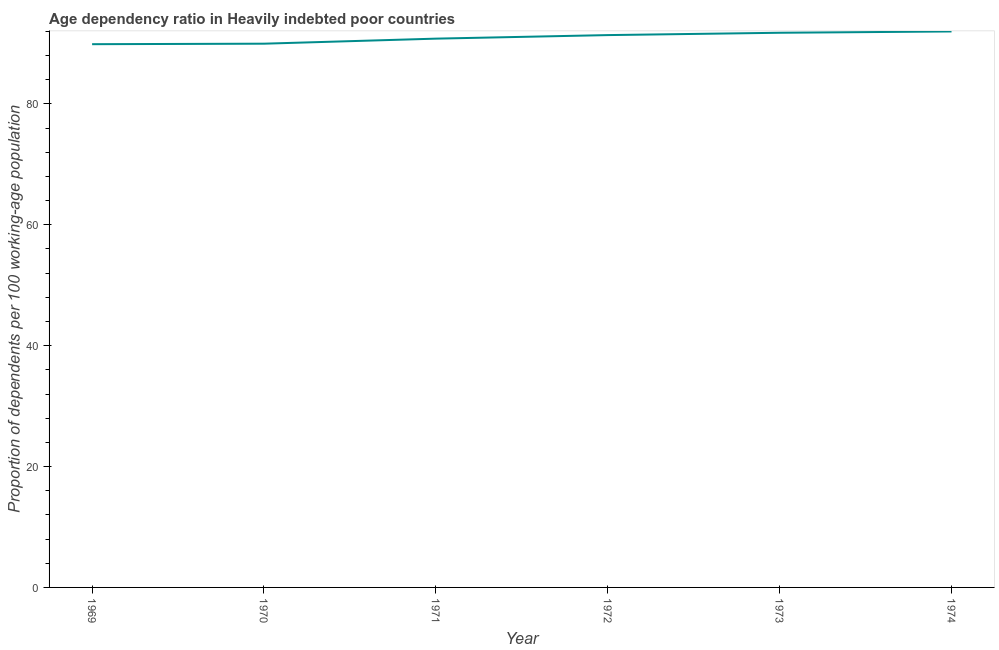What is the age dependency ratio in 1974?
Your answer should be compact. 91.99. Across all years, what is the maximum age dependency ratio?
Provide a short and direct response. 91.99. Across all years, what is the minimum age dependency ratio?
Offer a very short reply. 89.89. In which year was the age dependency ratio maximum?
Your answer should be very brief. 1974. In which year was the age dependency ratio minimum?
Your answer should be very brief. 1969. What is the sum of the age dependency ratio?
Your response must be concise. 545.82. What is the difference between the age dependency ratio in 1969 and 1972?
Your answer should be compact. -1.51. What is the average age dependency ratio per year?
Your answer should be compact. 90.97. What is the median age dependency ratio?
Provide a short and direct response. 91.1. What is the ratio of the age dependency ratio in 1973 to that in 1974?
Provide a short and direct response. 1. Is the age dependency ratio in 1971 less than that in 1974?
Make the answer very short. Yes. What is the difference between the highest and the second highest age dependency ratio?
Offer a very short reply. 0.22. What is the difference between the highest and the lowest age dependency ratio?
Your answer should be compact. 2.11. In how many years, is the age dependency ratio greater than the average age dependency ratio taken over all years?
Provide a succinct answer. 3. How many lines are there?
Give a very brief answer. 1. How many years are there in the graph?
Keep it short and to the point. 6. What is the difference between two consecutive major ticks on the Y-axis?
Your response must be concise. 20. Does the graph contain grids?
Give a very brief answer. No. What is the title of the graph?
Make the answer very short. Age dependency ratio in Heavily indebted poor countries. What is the label or title of the X-axis?
Make the answer very short. Year. What is the label or title of the Y-axis?
Give a very brief answer. Proportion of dependents per 100 working-age population. What is the Proportion of dependents per 100 working-age population of 1969?
Give a very brief answer. 89.89. What is the Proportion of dependents per 100 working-age population in 1970?
Provide a succinct answer. 89.97. What is the Proportion of dependents per 100 working-age population in 1971?
Provide a succinct answer. 90.8. What is the Proportion of dependents per 100 working-age population of 1972?
Keep it short and to the point. 91.39. What is the Proportion of dependents per 100 working-age population of 1973?
Your answer should be very brief. 91.78. What is the Proportion of dependents per 100 working-age population of 1974?
Provide a succinct answer. 91.99. What is the difference between the Proportion of dependents per 100 working-age population in 1969 and 1970?
Your response must be concise. -0.08. What is the difference between the Proportion of dependents per 100 working-age population in 1969 and 1971?
Offer a terse response. -0.92. What is the difference between the Proportion of dependents per 100 working-age population in 1969 and 1972?
Your response must be concise. -1.51. What is the difference between the Proportion of dependents per 100 working-age population in 1969 and 1973?
Your response must be concise. -1.89. What is the difference between the Proportion of dependents per 100 working-age population in 1969 and 1974?
Your answer should be compact. -2.11. What is the difference between the Proportion of dependents per 100 working-age population in 1970 and 1971?
Offer a very short reply. -0.83. What is the difference between the Proportion of dependents per 100 working-age population in 1970 and 1972?
Give a very brief answer. -1.42. What is the difference between the Proportion of dependents per 100 working-age population in 1970 and 1973?
Your answer should be very brief. -1.81. What is the difference between the Proportion of dependents per 100 working-age population in 1970 and 1974?
Your answer should be compact. -2.02. What is the difference between the Proportion of dependents per 100 working-age population in 1971 and 1972?
Give a very brief answer. -0.59. What is the difference between the Proportion of dependents per 100 working-age population in 1971 and 1973?
Provide a succinct answer. -0.97. What is the difference between the Proportion of dependents per 100 working-age population in 1971 and 1974?
Offer a terse response. -1.19. What is the difference between the Proportion of dependents per 100 working-age population in 1972 and 1973?
Ensure brevity in your answer.  -0.39. What is the difference between the Proportion of dependents per 100 working-age population in 1972 and 1974?
Your answer should be compact. -0.6. What is the difference between the Proportion of dependents per 100 working-age population in 1973 and 1974?
Your response must be concise. -0.22. What is the ratio of the Proportion of dependents per 100 working-age population in 1969 to that in 1971?
Keep it short and to the point. 0.99. What is the ratio of the Proportion of dependents per 100 working-age population in 1969 to that in 1973?
Offer a very short reply. 0.98. What is the ratio of the Proportion of dependents per 100 working-age population in 1969 to that in 1974?
Ensure brevity in your answer.  0.98. What is the ratio of the Proportion of dependents per 100 working-age population in 1970 to that in 1971?
Offer a very short reply. 0.99. What is the ratio of the Proportion of dependents per 100 working-age population in 1970 to that in 1972?
Offer a terse response. 0.98. What is the ratio of the Proportion of dependents per 100 working-age population in 1970 to that in 1974?
Provide a short and direct response. 0.98. What is the ratio of the Proportion of dependents per 100 working-age population in 1971 to that in 1972?
Keep it short and to the point. 0.99. What is the ratio of the Proportion of dependents per 100 working-age population in 1971 to that in 1973?
Offer a terse response. 0.99. What is the ratio of the Proportion of dependents per 100 working-age population in 1971 to that in 1974?
Keep it short and to the point. 0.99. What is the ratio of the Proportion of dependents per 100 working-age population in 1972 to that in 1973?
Your answer should be very brief. 1. What is the ratio of the Proportion of dependents per 100 working-age population in 1973 to that in 1974?
Your answer should be very brief. 1. 